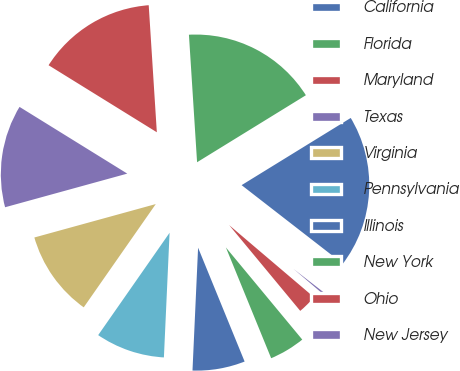Convert chart. <chart><loc_0><loc_0><loc_500><loc_500><pie_chart><fcel>California<fcel>Florida<fcel>Maryland<fcel>Texas<fcel>Virginia<fcel>Pennsylvania<fcel>Illinois<fcel>New York<fcel>Ohio<fcel>New Jersey<nl><fcel>19.29%<fcel>17.23%<fcel>15.16%<fcel>13.1%<fcel>11.03%<fcel>8.97%<fcel>6.9%<fcel>4.84%<fcel>2.77%<fcel>0.71%<nl></chart> 